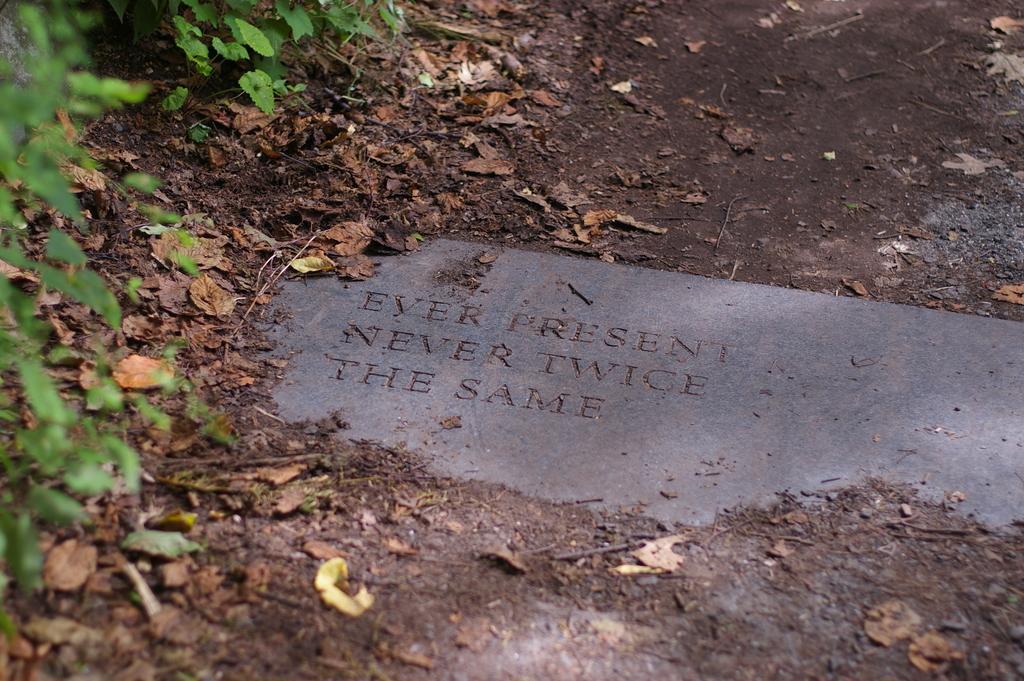Please provide a concise description of this image. In this image I can see number of green and brown colour leaves. Here I can see something is written. 